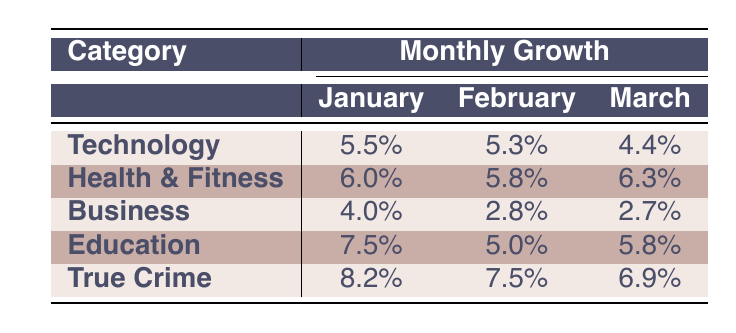What's the highest growth rate in January across all categories? The highest growth rate in January is found in the True Crime category, where the growth rate is 8.2%. This is determined by comparing all the January growth rates: 5.5% (Technology), 6.0% (Health & Fitness), 4.0% (Business), 7.5% (Education), and 8.2% (True Crime).
Answer: 8.2% How much did the number of uploads increase from January to March in the Health & Fitness category? In January, there were 1200 uploads and in March, there were 1350 uploads. To find the increase, subtract January uploads from March uploads: 1350 - 1200 = 150.
Answer: 150 Which category experienced a decline in growth rate from February to March? The Business category experienced a decline from February (2.8%) to March (2.7%). By checking the growth rates of all categories from February to March, we find that only Business has a lower growth rate in March.
Answer: Yes What is the total number of uploads in February across all categories? The total uploads in February can be calculated by adding the uploads of each category: 1580 (Technology) + 1270 (Health & Fitness) + 1850 (Business) + 945 (Education) + 860 (True Crime) = 5,505.
Answer: 5505 Which category has the most consistent growth rates across the months? The Technology category has growth rates of 5.5%, 5.3%, and 4.4%. The differences are relatively small compared to the more varied rates in other categories. Health & Fitness shows some consistency too but with slightly larger fluctuations.
Answer: Technology What is the average growth rate for the Education category? The growth rates for Education are 7.5%, 5.0%, and 5.8%. To find the average, sum these rates: 7.5 + 5.0 + 5.8 = 18.3. Then, divide by 3 (the number of months): 18.3 / 3 = 6.1.
Answer: 6.1 Did the True Crime category have more uploads in February than the Education category in January? In February, True Crime had 860 uploads, while Education had 900 uploads in January. So, True Crime did not have more uploads than Education in that comparison.
Answer: No Which category had the highest total uploads across January to March? By summing the total uploads for each category: Technology (1500 + 1580 + 1650 = 4730), Health & Fitness (1200 + 1270 + 1350 = 3820), Business (1800 + 1850 + 1900 = 5550), Education (900 + 945 + 1000 = 2845), and True Crime (800 + 860 + 920 = 2580). The highest is Business with 5550 uploads.
Answer: Business 